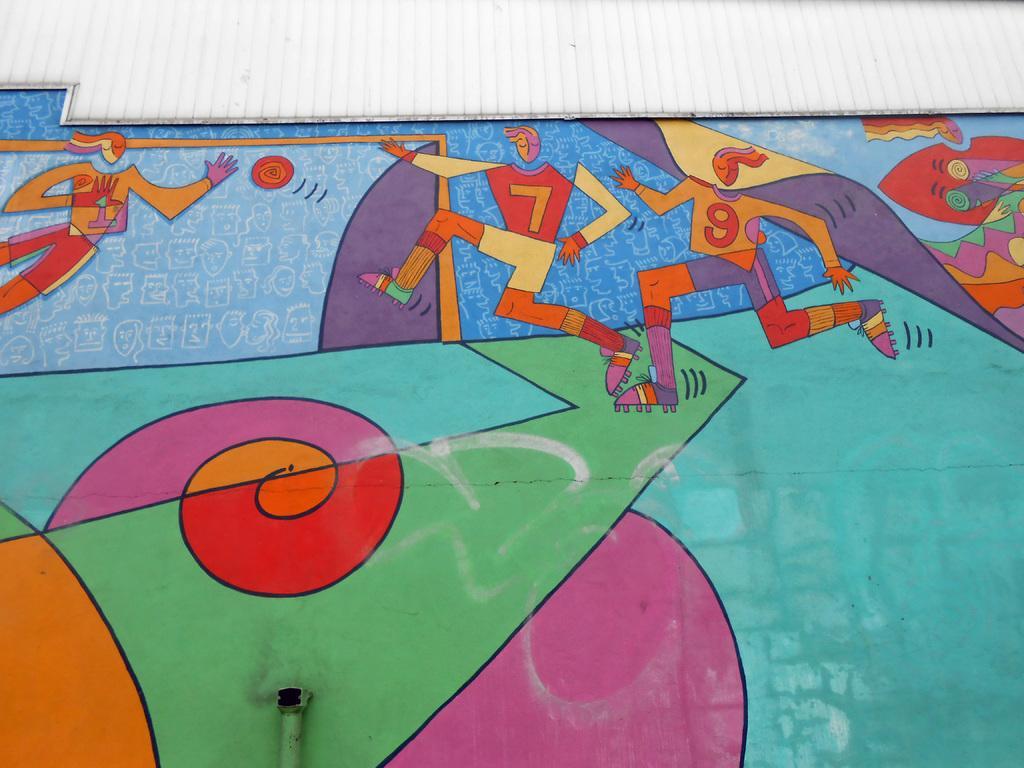Can you describe this image briefly? In the picture we can see a wall with a painting of some cartoon people. 